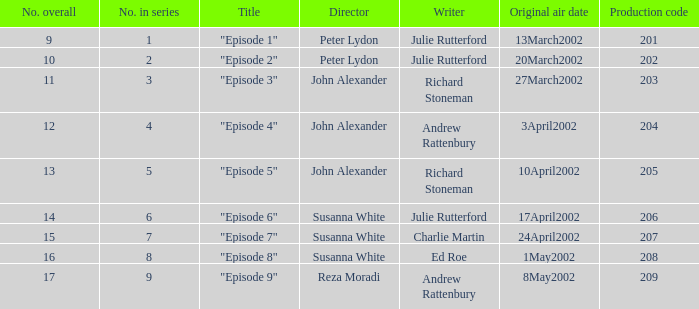What is the overall number when the title is "episode 1"? 9.0. 